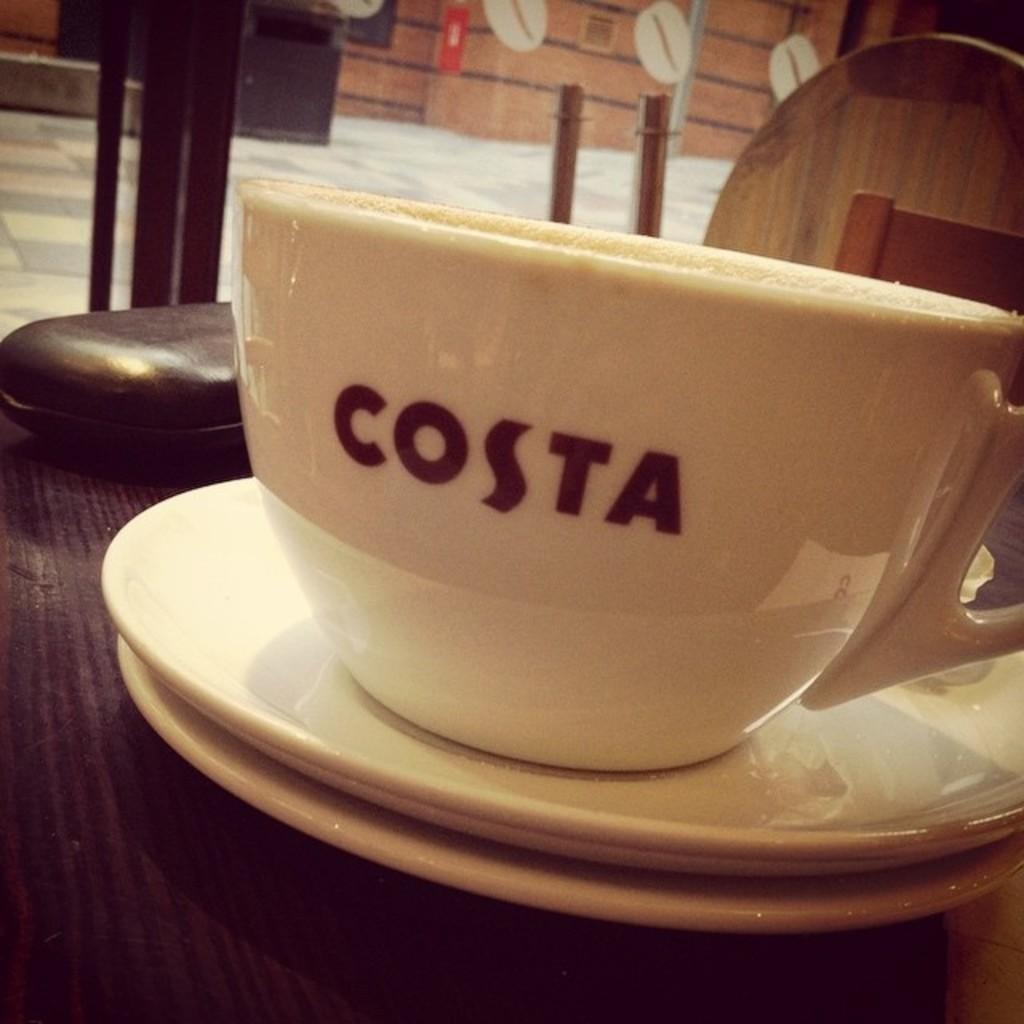What is present on the table in the image? There is a cup and saucers on a table in the image. Can you describe the objects on the table in more detail? The objects on the table include a cup and saucers. How many beds are visible in the image? There are no beds present in the image. What type of grip is required to hold the cup in the image? The image does not provide information about the grip required to hold the cup. 